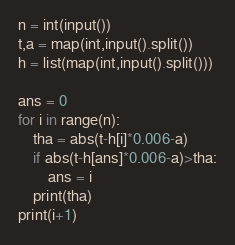Convert code to text. <code><loc_0><loc_0><loc_500><loc_500><_Python_>n = int(input())
t,a = map(int,input().split())
h = list(map(int,input().split()))

ans = 0
for i in range(n):
    tha = abs(t-h[i]*0.006-a)
    if abs(t-h[ans]*0.006-a)>tha:
        ans = i
    print(tha)
print(i+1)
</code> 